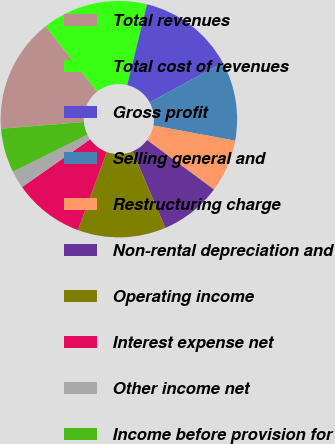Convert chart. <chart><loc_0><loc_0><loc_500><loc_500><pie_chart><fcel>Total revenues<fcel>Total cost of revenues<fcel>Gross profit<fcel>Selling general and<fcel>Restructuring charge<fcel>Non-rental depreciation and<fcel>Operating income<fcel>Interest expense net<fcel>Other income net<fcel>Income before provision for<nl><fcel>15.66%<fcel>14.46%<fcel>13.25%<fcel>10.84%<fcel>7.23%<fcel>8.43%<fcel>12.05%<fcel>9.64%<fcel>2.41%<fcel>6.03%<nl></chart> 